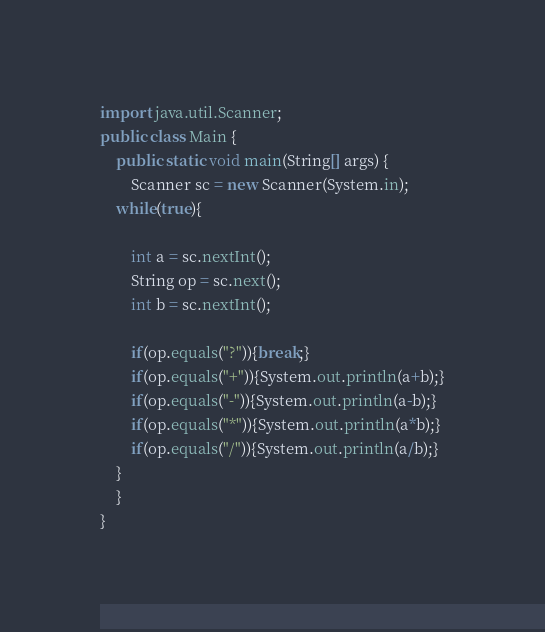<code> <loc_0><loc_0><loc_500><loc_500><_Java_>import java.util.Scanner;
public class Main {
    public static void main(String[] args) {
    	Scanner sc = new Scanner(System.in);
    while(true){
    		
		int a = sc.nextInt();
		String op = sc.next();
		int b = sc.nextInt();
		
		if(op.equals("?")){break;}
		if(op.equals("+")){System.out.println(a+b);}
		if(op.equals("-")){System.out.println(a-b);}
		if(op.equals("*")){System.out.println(a*b);}
		if(op.equals("/")){System.out.println(a/b);}
	}
    }
}
</code> 